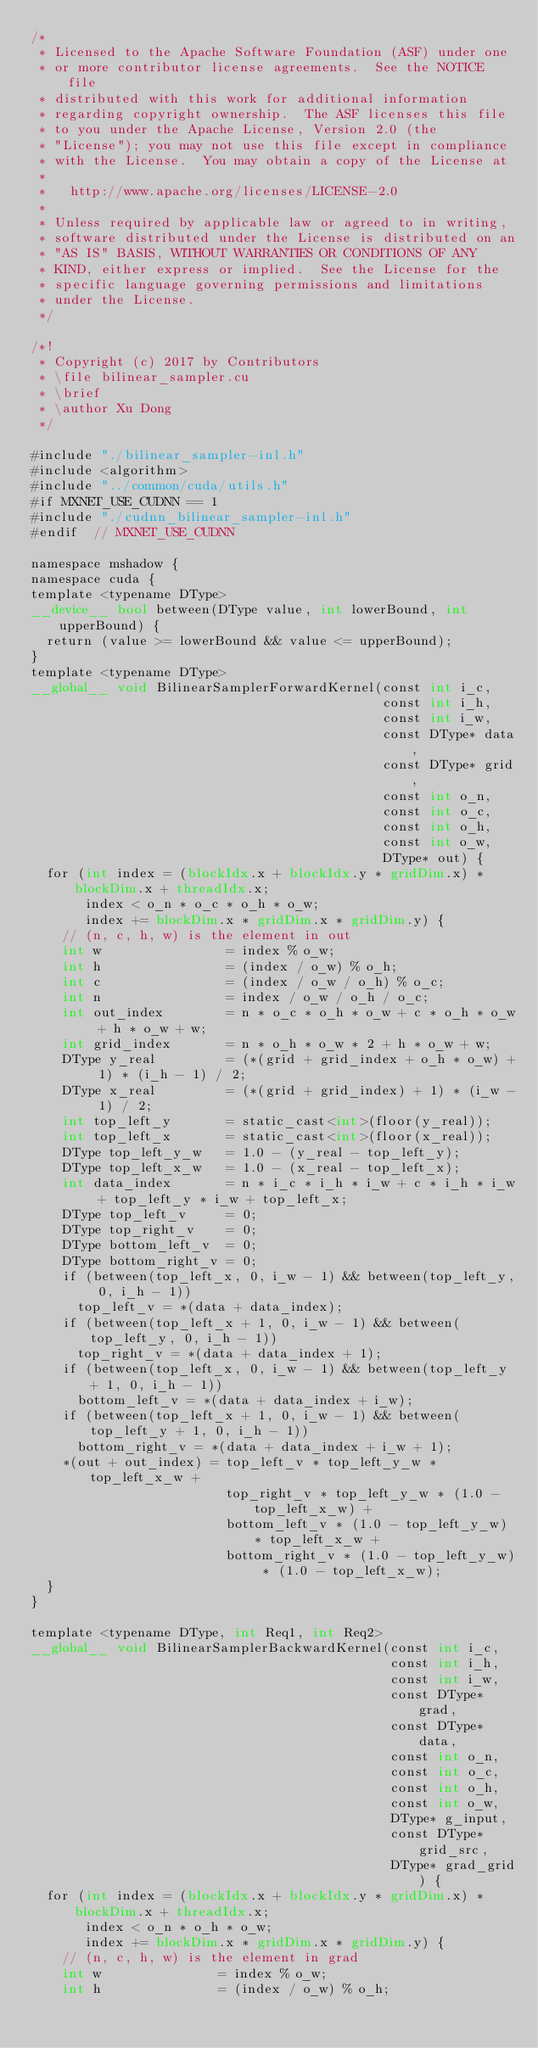Convert code to text. <code><loc_0><loc_0><loc_500><loc_500><_Cuda_>/*
 * Licensed to the Apache Software Foundation (ASF) under one
 * or more contributor license agreements.  See the NOTICE file
 * distributed with this work for additional information
 * regarding copyright ownership.  The ASF licenses this file
 * to you under the Apache License, Version 2.0 (the
 * "License"); you may not use this file except in compliance
 * with the License.  You may obtain a copy of the License at
 *
 *   http://www.apache.org/licenses/LICENSE-2.0
 *
 * Unless required by applicable law or agreed to in writing,
 * software distributed under the License is distributed on an
 * "AS IS" BASIS, WITHOUT WARRANTIES OR CONDITIONS OF ANY
 * KIND, either express or implied.  See the License for the
 * specific language governing permissions and limitations
 * under the License.
 */

/*!
 * Copyright (c) 2017 by Contributors
 * \file bilinear_sampler.cu
 * \brief
 * \author Xu Dong
 */

#include "./bilinear_sampler-inl.h"
#include <algorithm>
#include "../common/cuda/utils.h"
#if MXNET_USE_CUDNN == 1
#include "./cudnn_bilinear_sampler-inl.h"
#endif  // MXNET_USE_CUDNN

namespace mshadow {
namespace cuda {
template <typename DType>
__device__ bool between(DType value, int lowerBound, int upperBound) {
  return (value >= lowerBound && value <= upperBound);
}
template <typename DType>
__global__ void BilinearSamplerForwardKernel(const int i_c,
                                             const int i_h,
                                             const int i_w,
                                             const DType* data,
                                             const DType* grid,
                                             const int o_n,
                                             const int o_c,
                                             const int o_h,
                                             const int o_w,
                                             DType* out) {
  for (int index = (blockIdx.x + blockIdx.y * gridDim.x) * blockDim.x + threadIdx.x;
       index < o_n * o_c * o_h * o_w;
       index += blockDim.x * gridDim.x * gridDim.y) {
    // (n, c, h, w) is the element in out
    int w                = index % o_w;
    int h                = (index / o_w) % o_h;
    int c                = (index / o_w / o_h) % o_c;
    int n                = index / o_w / o_h / o_c;
    int out_index        = n * o_c * o_h * o_w + c * o_h * o_w + h * o_w + w;
    int grid_index       = n * o_h * o_w * 2 + h * o_w + w;
    DType y_real         = (*(grid + grid_index + o_h * o_w) + 1) * (i_h - 1) / 2;
    DType x_real         = (*(grid + grid_index) + 1) * (i_w - 1) / 2;
    int top_left_y       = static_cast<int>(floor(y_real));
    int top_left_x       = static_cast<int>(floor(x_real));
    DType top_left_y_w   = 1.0 - (y_real - top_left_y);
    DType top_left_x_w   = 1.0 - (x_real - top_left_x);
    int data_index       = n * i_c * i_h * i_w + c * i_h * i_w + top_left_y * i_w + top_left_x;
    DType top_left_v     = 0;
    DType top_right_v    = 0;
    DType bottom_left_v  = 0;
    DType bottom_right_v = 0;
    if (between(top_left_x, 0, i_w - 1) && between(top_left_y, 0, i_h - 1))
      top_left_v = *(data + data_index);
    if (between(top_left_x + 1, 0, i_w - 1) && between(top_left_y, 0, i_h - 1))
      top_right_v = *(data + data_index + 1);
    if (between(top_left_x, 0, i_w - 1) && between(top_left_y + 1, 0, i_h - 1))
      bottom_left_v = *(data + data_index + i_w);
    if (between(top_left_x + 1, 0, i_w - 1) && between(top_left_y + 1, 0, i_h - 1))
      bottom_right_v = *(data + data_index + i_w + 1);
    *(out + out_index) = top_left_v * top_left_y_w * top_left_x_w +
                         top_right_v * top_left_y_w * (1.0 - top_left_x_w) +
                         bottom_left_v * (1.0 - top_left_y_w) * top_left_x_w +
                         bottom_right_v * (1.0 - top_left_y_w) * (1.0 - top_left_x_w);
  }
}

template <typename DType, int Req1, int Req2>
__global__ void BilinearSamplerBackwardKernel(const int i_c,
                                              const int i_h,
                                              const int i_w,
                                              const DType* grad,
                                              const DType* data,
                                              const int o_n,
                                              const int o_c,
                                              const int o_h,
                                              const int o_w,
                                              DType* g_input,
                                              const DType* grid_src,
                                              DType* grad_grid) {
  for (int index = (blockIdx.x + blockIdx.y * gridDim.x) * blockDim.x + threadIdx.x;
       index < o_n * o_h * o_w;
       index += blockDim.x * gridDim.x * gridDim.y) {
    // (n, c, h, w) is the element in grad
    int w               = index % o_w;
    int h               = (index / o_w) % o_h;</code> 